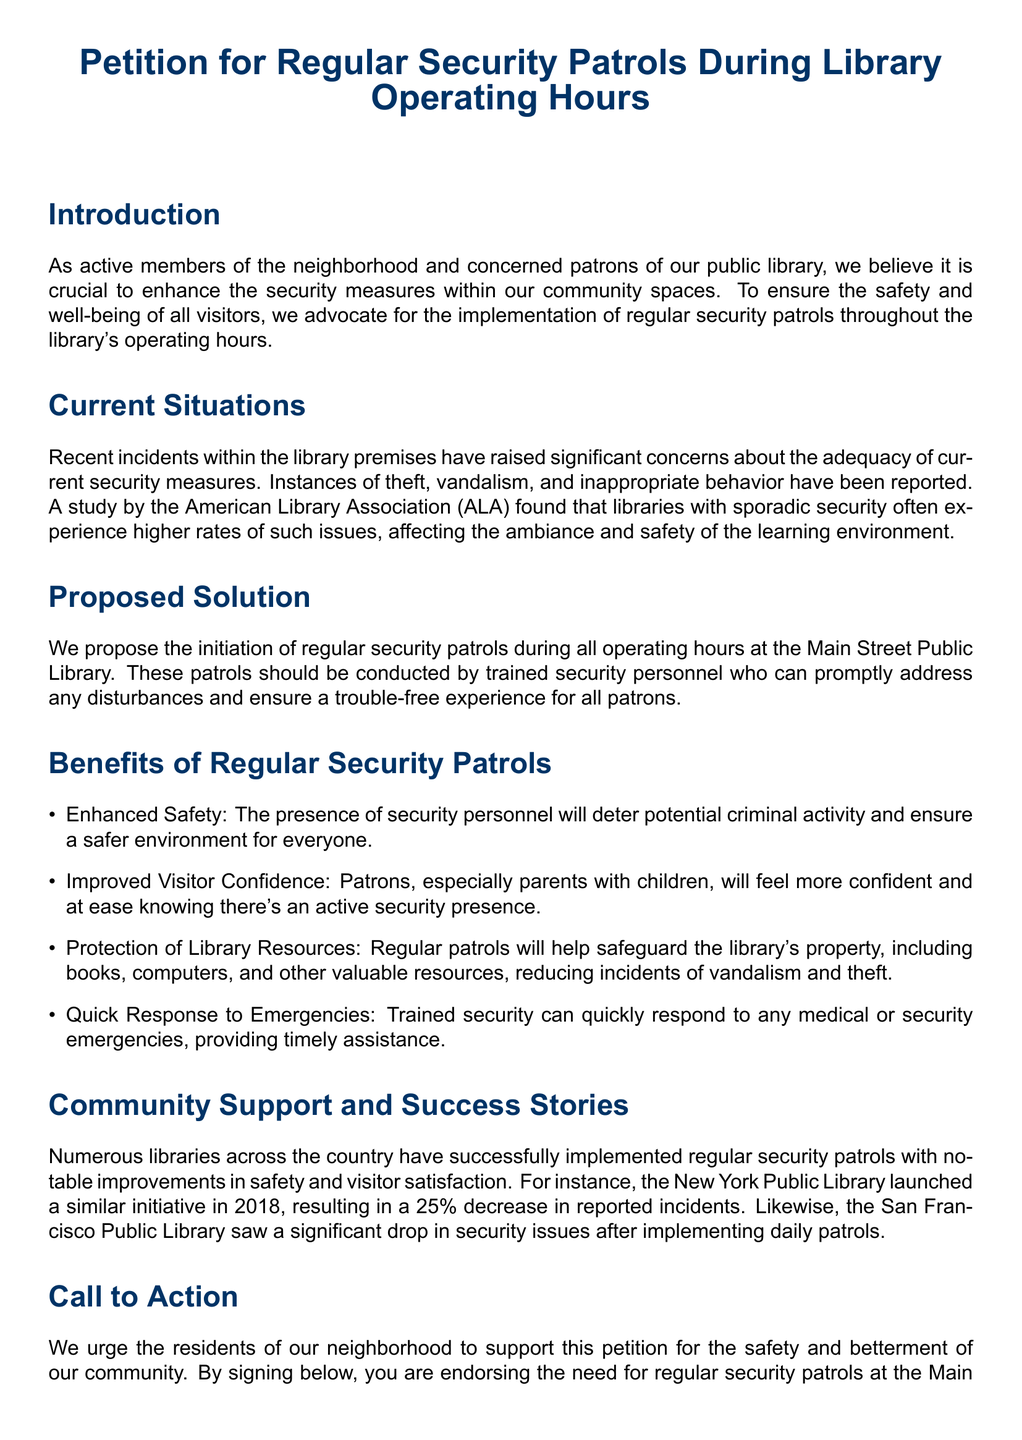what is the title of the petition? The title of the petition is stated at the beginning of the document, emphasizing the request for regular security patrols.
Answer: Petition for Regular Security Patrols During Library Operating Hours how many benefits of regular security patrols are listed? The benefits of regular security patrols are enumerated in a list, which counts to four distinct benefits.
Answer: 4 who is the author of the petition? The petition does not specify an individual author but refers to "active members of the neighborhood and concerned patrons" as the advocates for the petition.
Answer: Active members of the neighborhood what year did the New York Public Library launch their security patrol initiative? The document includes specific details about the New York Public Library's initiative, specifically mentioning the year when it was launched.
Answer: 2018 what percentage decrease did the New York Public Library see in reported incidents? The document cites a specific statistic regarding the effectiveness of security patrols in reducing incidents, noting a percentage of decrease.
Answer: 25% what is the purpose of the call to action section? The call to action section aims to mobilize support from the community to endorse the petition for security patrols at the library.
Answer: Mobilize support how many signatures are provided for endorsement? The petition has a signature section designed for collection, organized for a total of nine signatures.
Answer: 9 what type of incidents prompted the petition? The introduction of the petition mentions the types of negative occurrences that have raised concerns among library visitors.
Answer: Theft, vandalism, and inappropriate behavior which library system is mentioned as having successfully implemented security patrols? The document provides examples of libraries that have had success with security patrols, specifically naming one of them as a success story.
Answer: San Francisco Public Library 